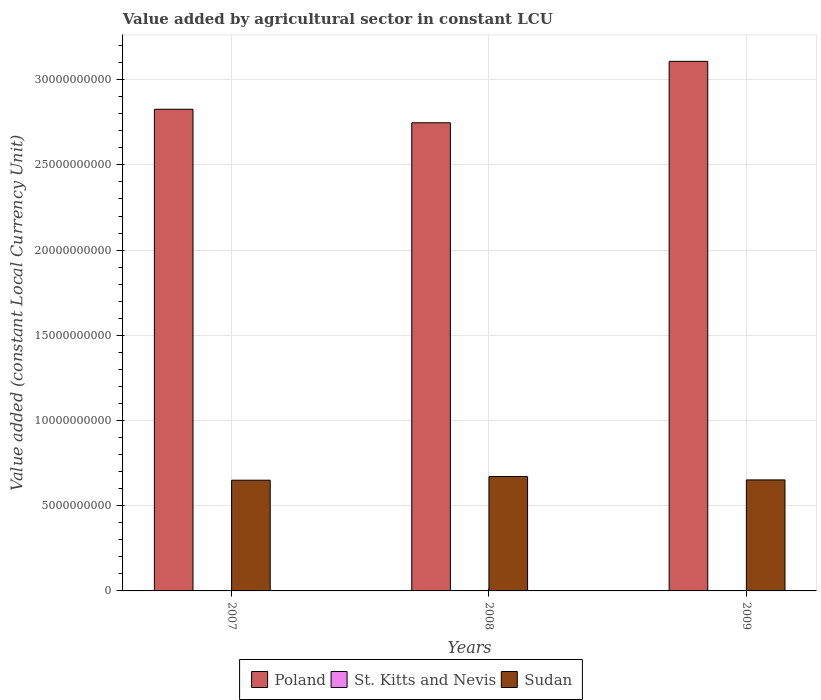Are the number of bars on each tick of the X-axis equal?
Make the answer very short. Yes. How many bars are there on the 2nd tick from the left?
Provide a succinct answer. 3. How many bars are there on the 3rd tick from the right?
Give a very brief answer. 3. What is the label of the 2nd group of bars from the left?
Provide a short and direct response. 2008. In how many cases, is the number of bars for a given year not equal to the number of legend labels?
Offer a very short reply. 0. What is the value added by agricultural sector in St. Kitts and Nevis in 2008?
Provide a succinct answer. 2.26e+07. Across all years, what is the maximum value added by agricultural sector in St. Kitts and Nevis?
Your answer should be very brief. 2.26e+07. Across all years, what is the minimum value added by agricultural sector in Sudan?
Provide a succinct answer. 6.50e+09. What is the total value added by agricultural sector in Poland in the graph?
Your answer should be very brief. 8.68e+1. What is the difference between the value added by agricultural sector in Sudan in 2007 and that in 2008?
Offer a terse response. -2.18e+08. What is the difference between the value added by agricultural sector in Sudan in 2007 and the value added by agricultural sector in St. Kitts and Nevis in 2008?
Offer a terse response. 6.47e+09. What is the average value added by agricultural sector in Sudan per year?
Provide a short and direct response. 6.57e+09. In the year 2007, what is the difference between the value added by agricultural sector in Poland and value added by agricultural sector in St. Kitts and Nevis?
Your response must be concise. 2.82e+1. In how many years, is the value added by agricultural sector in Sudan greater than 7000000000 LCU?
Provide a short and direct response. 0. What is the ratio of the value added by agricultural sector in Poland in 2007 to that in 2009?
Your response must be concise. 0.91. Is the value added by agricultural sector in Poland in 2007 less than that in 2008?
Keep it short and to the point. No. Is the difference between the value added by agricultural sector in Poland in 2007 and 2009 greater than the difference between the value added by agricultural sector in St. Kitts and Nevis in 2007 and 2009?
Give a very brief answer. No. What is the difference between the highest and the second highest value added by agricultural sector in Poland?
Give a very brief answer. 2.81e+09. What is the difference between the highest and the lowest value added by agricultural sector in St. Kitts and Nevis?
Offer a very short reply. 2.39e+06. Is the sum of the value added by agricultural sector in Sudan in 2007 and 2008 greater than the maximum value added by agricultural sector in Poland across all years?
Your answer should be compact. No. What does the 3rd bar from the left in 2008 represents?
Your answer should be very brief. Sudan. What does the 3rd bar from the right in 2009 represents?
Offer a very short reply. Poland. Are all the bars in the graph horizontal?
Give a very brief answer. No. How many years are there in the graph?
Make the answer very short. 3. What is the difference between two consecutive major ticks on the Y-axis?
Keep it short and to the point. 5.00e+09. Does the graph contain grids?
Provide a short and direct response. Yes. How many legend labels are there?
Ensure brevity in your answer.  3. What is the title of the graph?
Ensure brevity in your answer.  Value added by agricultural sector in constant LCU. What is the label or title of the Y-axis?
Offer a terse response. Value added (constant Local Currency Unit). What is the Value added (constant Local Currency Unit) in Poland in 2007?
Offer a terse response. 2.83e+1. What is the Value added (constant Local Currency Unit) of St. Kitts and Nevis in 2007?
Give a very brief answer. 2.13e+07. What is the Value added (constant Local Currency Unit) in Sudan in 2007?
Ensure brevity in your answer.  6.50e+09. What is the Value added (constant Local Currency Unit) in Poland in 2008?
Ensure brevity in your answer.  2.75e+1. What is the Value added (constant Local Currency Unit) of St. Kitts and Nevis in 2008?
Your answer should be compact. 2.26e+07. What is the Value added (constant Local Currency Unit) of Sudan in 2008?
Make the answer very short. 6.71e+09. What is the Value added (constant Local Currency Unit) in Poland in 2009?
Ensure brevity in your answer.  3.11e+1. What is the Value added (constant Local Currency Unit) of St. Kitts and Nevis in 2009?
Your answer should be very brief. 2.02e+07. What is the Value added (constant Local Currency Unit) of Sudan in 2009?
Offer a terse response. 6.51e+09. Across all years, what is the maximum Value added (constant Local Currency Unit) of Poland?
Ensure brevity in your answer.  3.11e+1. Across all years, what is the maximum Value added (constant Local Currency Unit) in St. Kitts and Nevis?
Offer a very short reply. 2.26e+07. Across all years, what is the maximum Value added (constant Local Currency Unit) in Sudan?
Your answer should be very brief. 6.71e+09. Across all years, what is the minimum Value added (constant Local Currency Unit) in Poland?
Make the answer very short. 2.75e+1. Across all years, what is the minimum Value added (constant Local Currency Unit) in St. Kitts and Nevis?
Your response must be concise. 2.02e+07. Across all years, what is the minimum Value added (constant Local Currency Unit) of Sudan?
Keep it short and to the point. 6.50e+09. What is the total Value added (constant Local Currency Unit) in Poland in the graph?
Give a very brief answer. 8.68e+1. What is the total Value added (constant Local Currency Unit) of St. Kitts and Nevis in the graph?
Your response must be concise. 6.41e+07. What is the total Value added (constant Local Currency Unit) in Sudan in the graph?
Your response must be concise. 1.97e+1. What is the difference between the Value added (constant Local Currency Unit) of Poland in 2007 and that in 2008?
Give a very brief answer. 7.92e+08. What is the difference between the Value added (constant Local Currency Unit) of St. Kitts and Nevis in 2007 and that in 2008?
Your answer should be very brief. -1.21e+06. What is the difference between the Value added (constant Local Currency Unit) in Sudan in 2007 and that in 2008?
Provide a succinct answer. -2.18e+08. What is the difference between the Value added (constant Local Currency Unit) of Poland in 2007 and that in 2009?
Keep it short and to the point. -2.81e+09. What is the difference between the Value added (constant Local Currency Unit) in St. Kitts and Nevis in 2007 and that in 2009?
Offer a very short reply. 1.18e+06. What is the difference between the Value added (constant Local Currency Unit) in Sudan in 2007 and that in 2009?
Your answer should be very brief. -1.81e+07. What is the difference between the Value added (constant Local Currency Unit) of Poland in 2008 and that in 2009?
Your answer should be compact. -3.60e+09. What is the difference between the Value added (constant Local Currency Unit) of St. Kitts and Nevis in 2008 and that in 2009?
Provide a short and direct response. 2.39e+06. What is the difference between the Value added (constant Local Currency Unit) in Sudan in 2008 and that in 2009?
Provide a short and direct response. 1.99e+08. What is the difference between the Value added (constant Local Currency Unit) of Poland in 2007 and the Value added (constant Local Currency Unit) of St. Kitts and Nevis in 2008?
Give a very brief answer. 2.82e+1. What is the difference between the Value added (constant Local Currency Unit) in Poland in 2007 and the Value added (constant Local Currency Unit) in Sudan in 2008?
Offer a terse response. 2.16e+1. What is the difference between the Value added (constant Local Currency Unit) in St. Kitts and Nevis in 2007 and the Value added (constant Local Currency Unit) in Sudan in 2008?
Offer a terse response. -6.69e+09. What is the difference between the Value added (constant Local Currency Unit) of Poland in 2007 and the Value added (constant Local Currency Unit) of St. Kitts and Nevis in 2009?
Offer a terse response. 2.82e+1. What is the difference between the Value added (constant Local Currency Unit) in Poland in 2007 and the Value added (constant Local Currency Unit) in Sudan in 2009?
Ensure brevity in your answer.  2.17e+1. What is the difference between the Value added (constant Local Currency Unit) of St. Kitts and Nevis in 2007 and the Value added (constant Local Currency Unit) of Sudan in 2009?
Your answer should be compact. -6.49e+09. What is the difference between the Value added (constant Local Currency Unit) in Poland in 2008 and the Value added (constant Local Currency Unit) in St. Kitts and Nevis in 2009?
Give a very brief answer. 2.75e+1. What is the difference between the Value added (constant Local Currency Unit) of Poland in 2008 and the Value added (constant Local Currency Unit) of Sudan in 2009?
Ensure brevity in your answer.  2.10e+1. What is the difference between the Value added (constant Local Currency Unit) in St. Kitts and Nevis in 2008 and the Value added (constant Local Currency Unit) in Sudan in 2009?
Ensure brevity in your answer.  -6.49e+09. What is the average Value added (constant Local Currency Unit) in Poland per year?
Ensure brevity in your answer.  2.89e+1. What is the average Value added (constant Local Currency Unit) in St. Kitts and Nevis per year?
Ensure brevity in your answer.  2.14e+07. What is the average Value added (constant Local Currency Unit) in Sudan per year?
Your answer should be very brief. 6.57e+09. In the year 2007, what is the difference between the Value added (constant Local Currency Unit) in Poland and Value added (constant Local Currency Unit) in St. Kitts and Nevis?
Your answer should be very brief. 2.82e+1. In the year 2007, what is the difference between the Value added (constant Local Currency Unit) of Poland and Value added (constant Local Currency Unit) of Sudan?
Your response must be concise. 2.18e+1. In the year 2007, what is the difference between the Value added (constant Local Currency Unit) in St. Kitts and Nevis and Value added (constant Local Currency Unit) in Sudan?
Offer a very short reply. -6.47e+09. In the year 2008, what is the difference between the Value added (constant Local Currency Unit) in Poland and Value added (constant Local Currency Unit) in St. Kitts and Nevis?
Ensure brevity in your answer.  2.74e+1. In the year 2008, what is the difference between the Value added (constant Local Currency Unit) in Poland and Value added (constant Local Currency Unit) in Sudan?
Your answer should be compact. 2.08e+1. In the year 2008, what is the difference between the Value added (constant Local Currency Unit) of St. Kitts and Nevis and Value added (constant Local Currency Unit) of Sudan?
Give a very brief answer. -6.69e+09. In the year 2009, what is the difference between the Value added (constant Local Currency Unit) of Poland and Value added (constant Local Currency Unit) of St. Kitts and Nevis?
Your answer should be compact. 3.11e+1. In the year 2009, what is the difference between the Value added (constant Local Currency Unit) of Poland and Value added (constant Local Currency Unit) of Sudan?
Your answer should be very brief. 2.46e+1. In the year 2009, what is the difference between the Value added (constant Local Currency Unit) in St. Kitts and Nevis and Value added (constant Local Currency Unit) in Sudan?
Ensure brevity in your answer.  -6.49e+09. What is the ratio of the Value added (constant Local Currency Unit) of Poland in 2007 to that in 2008?
Your answer should be very brief. 1.03. What is the ratio of the Value added (constant Local Currency Unit) of St. Kitts and Nevis in 2007 to that in 2008?
Provide a short and direct response. 0.95. What is the ratio of the Value added (constant Local Currency Unit) of Sudan in 2007 to that in 2008?
Your answer should be compact. 0.97. What is the ratio of the Value added (constant Local Currency Unit) of Poland in 2007 to that in 2009?
Your response must be concise. 0.91. What is the ratio of the Value added (constant Local Currency Unit) of St. Kitts and Nevis in 2007 to that in 2009?
Your answer should be very brief. 1.06. What is the ratio of the Value added (constant Local Currency Unit) of Poland in 2008 to that in 2009?
Your response must be concise. 0.88. What is the ratio of the Value added (constant Local Currency Unit) in St. Kitts and Nevis in 2008 to that in 2009?
Make the answer very short. 1.12. What is the ratio of the Value added (constant Local Currency Unit) of Sudan in 2008 to that in 2009?
Your answer should be very brief. 1.03. What is the difference between the highest and the second highest Value added (constant Local Currency Unit) in Poland?
Provide a short and direct response. 2.81e+09. What is the difference between the highest and the second highest Value added (constant Local Currency Unit) of St. Kitts and Nevis?
Make the answer very short. 1.21e+06. What is the difference between the highest and the second highest Value added (constant Local Currency Unit) of Sudan?
Your answer should be very brief. 1.99e+08. What is the difference between the highest and the lowest Value added (constant Local Currency Unit) of Poland?
Ensure brevity in your answer.  3.60e+09. What is the difference between the highest and the lowest Value added (constant Local Currency Unit) in St. Kitts and Nevis?
Provide a short and direct response. 2.39e+06. What is the difference between the highest and the lowest Value added (constant Local Currency Unit) in Sudan?
Provide a short and direct response. 2.18e+08. 